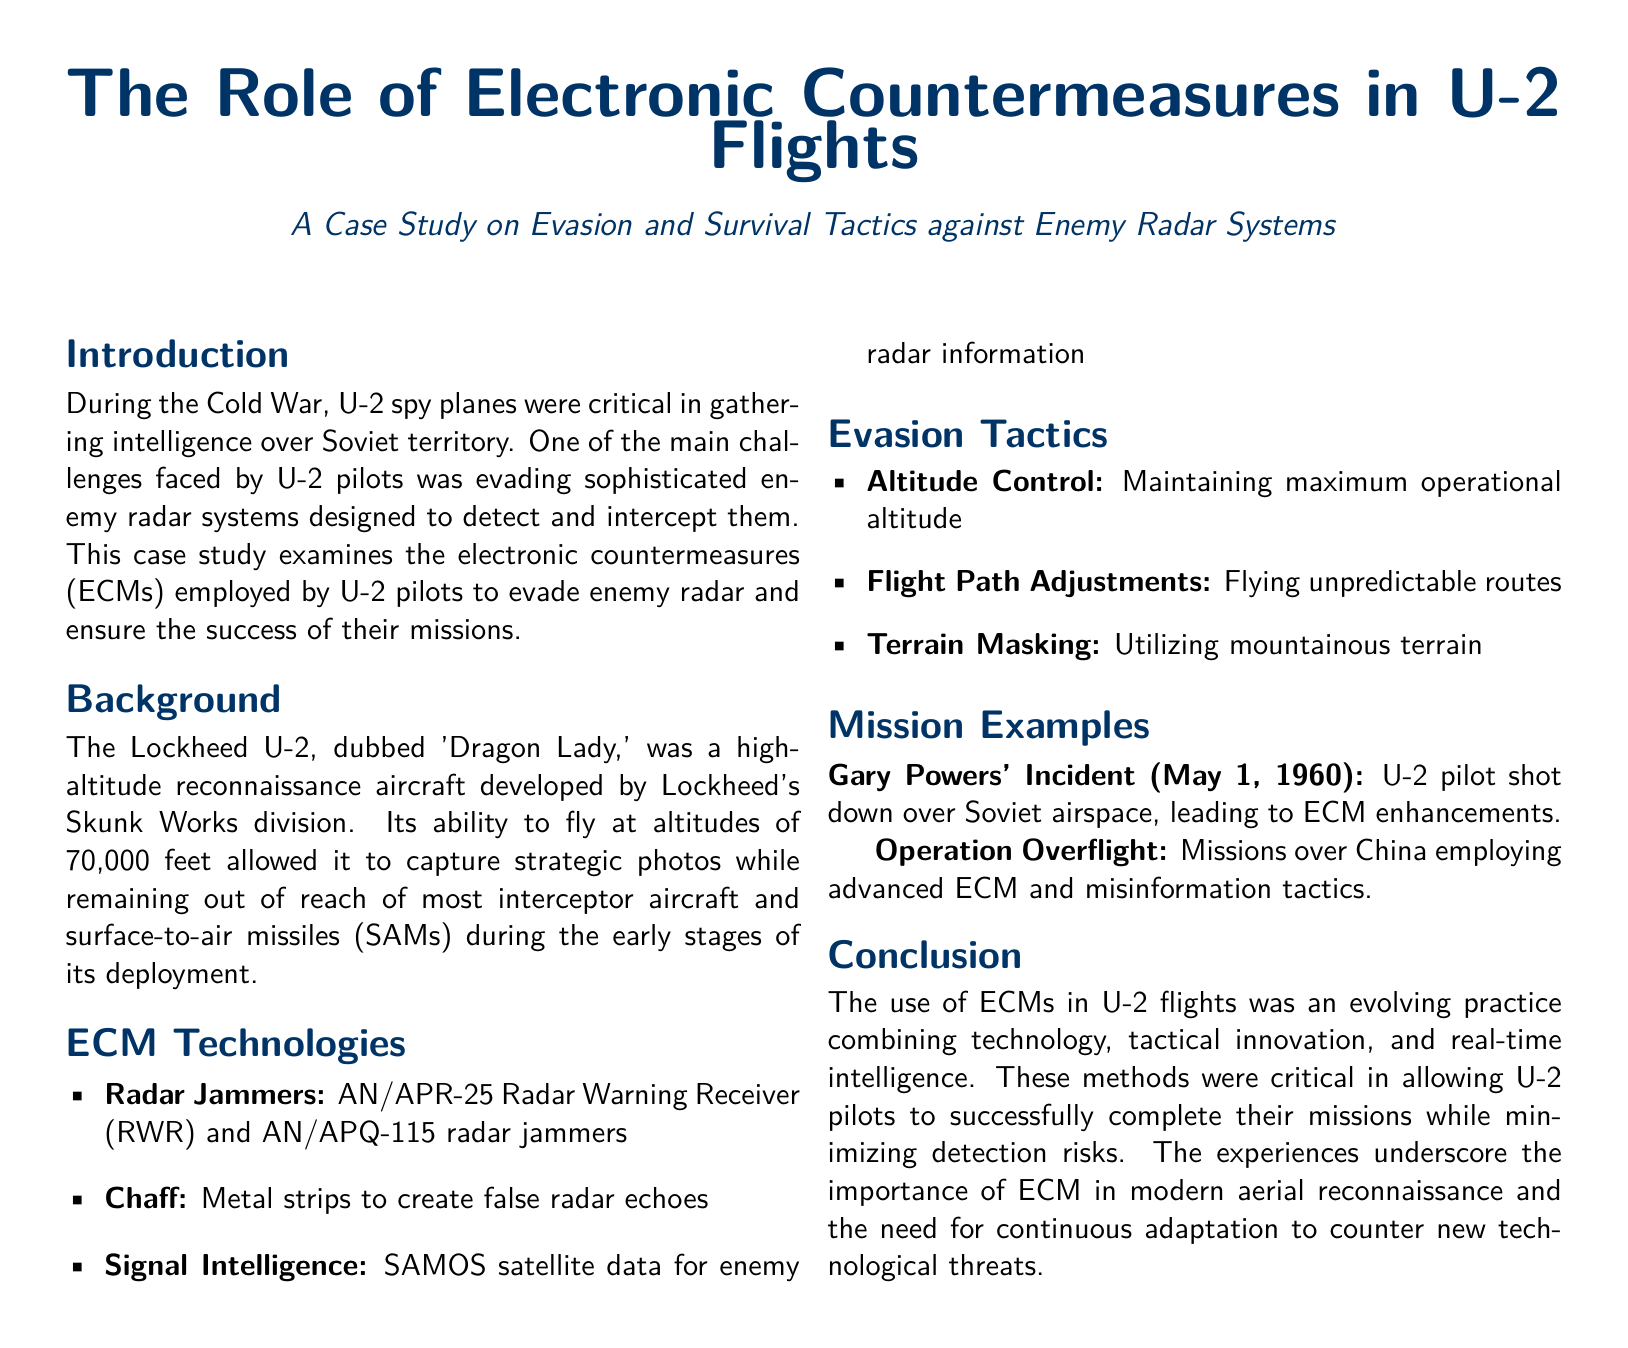What was the altitude capability of the U-2? The document states that the U-2 could fly at altitudes of 70,000 feet.
Answer: 70,000 feet What is the nickname of the Lockheed U-2? The document refers to the U-2 as 'Dragon Lady'.
Answer: Dragon Lady What electronic countermeasure is associated with creating false radar echoes? The document mentions that chaff, which consists of metal strips, creates false radar echoes.
Answer: Chaff Which significant incident led to ECM enhancements? According to the document, the incident involving Gary Powers on May 1, 1960, led to ECM enhancements.
Answer: Gary Powers' Incident What tactic involves using mountainous terrain for evasion? The document names "Terrain Masking" as a tactic that utilizes mountainous terrain.
Answer: Terrain Masking What were the names of the two radar jamming technologies mentioned? The document lists AN/APR-25 Radar Warning Receiver (RWR) and AN/APQ-115 radar jammers as the technologies.
Answer: AN/APR-25 and AN/APQ-115 What type of intelligence was used for enemy radar information? The document specifies that Signal Intelligence and SAMOS satellite data were used for this purpose.
Answer: Signal Intelligence What was a key strategy for U-2 pilots to avoid detection? The document talks about maintaining maximum operational altitude as a key strategy.
Answer: Altitude Control How did the U-2 pilots adapt to technological threats? The document concludes that pilots used evolving practices combining technology and tactical innovation to adapt.
Answer: Evolving practices 